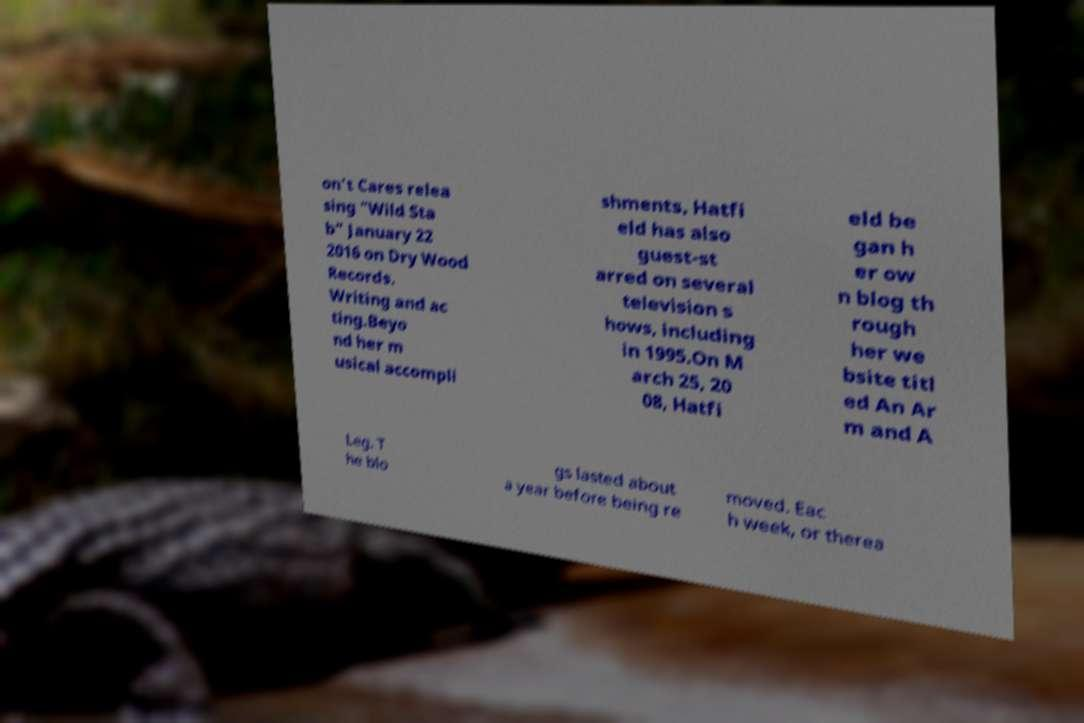Could you extract and type out the text from this image? on't Cares relea sing "Wild Sta b" January 22 2016 on Dry Wood Records. Writing and ac ting.Beyo nd her m usical accompli shments, Hatfi eld has also guest-st arred on several television s hows, including in 1995.On M arch 25, 20 08, Hatfi eld be gan h er ow n blog th rough her we bsite titl ed An Ar m and A Leg. T he blo gs lasted about a year before being re moved. Eac h week, or therea 